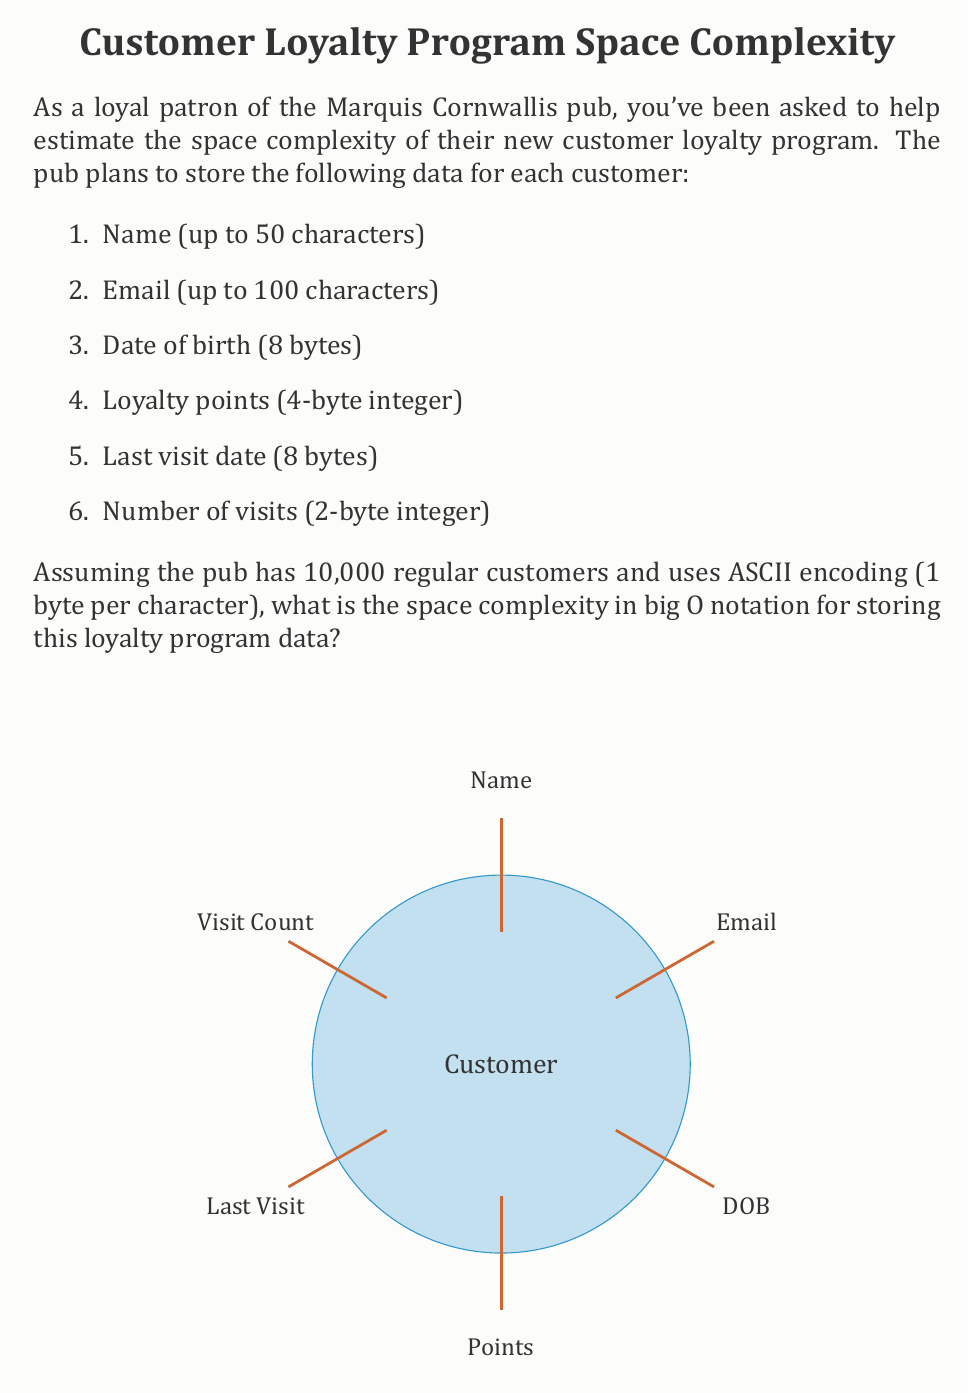Solve this math problem. Let's break down the space required for each customer:

1. Name: 50 characters * 1 byte/character = 50 bytes
2. Email: 100 characters * 1 byte/character = 100 bytes
3. Date of birth: 8 bytes
4. Loyalty points: 4 bytes
5. Last visit date: 8 bytes
6. Number of visits: 2 bytes

Total space per customer = 50 + 100 + 8 + 4 + 8 + 2 = 172 bytes

Now, let's consider the total space for all customers:

Total space = Space per customer * Number of customers
            = 172 bytes * 10,000
            = 1,720,000 bytes

In big O notation, we're interested in how the space requirements grow with the number of customers. Let $n$ be the number of customers. The space required grows linearly with $n$, as each new customer adds a fixed amount of data.

The space complexity can be expressed as $O(n)$, where $n$ is the number of customers.

This is because:
1. The space for each customer is constant (172 bytes).
2. The total space is directly proportional to the number of customers.
3. We ignore constant factors in big O notation.

Even if the pub were to add more fields or increase the size of existing fields, as long as the data per customer remains constant, the space complexity would still be $O(n)$.
Answer: $O(n)$ 